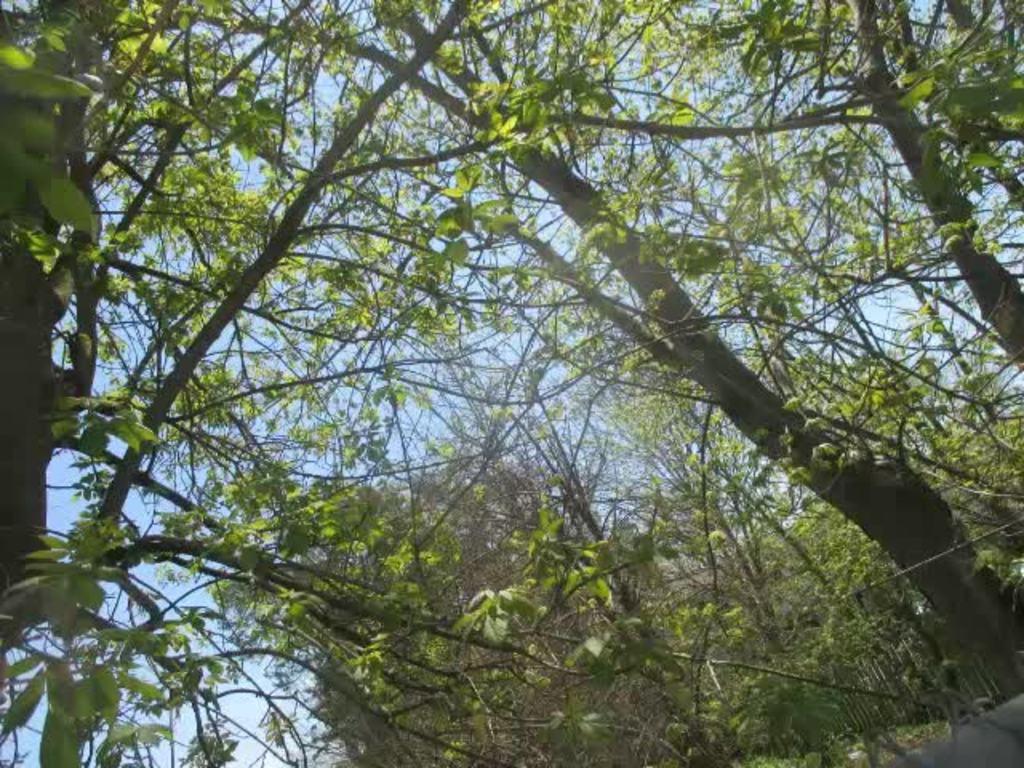In one or two sentences, can you explain what this image depicts? In this image we can see trees. 